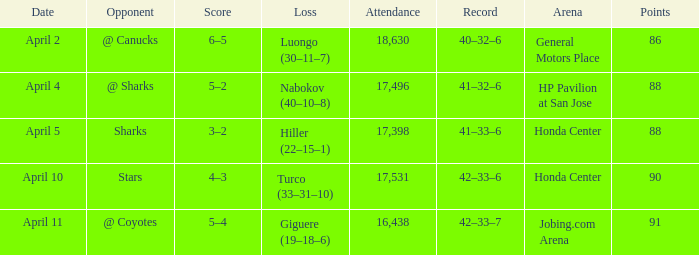How many Points have a Score of 3–2, and an Attendance larger than 17,398? None. 